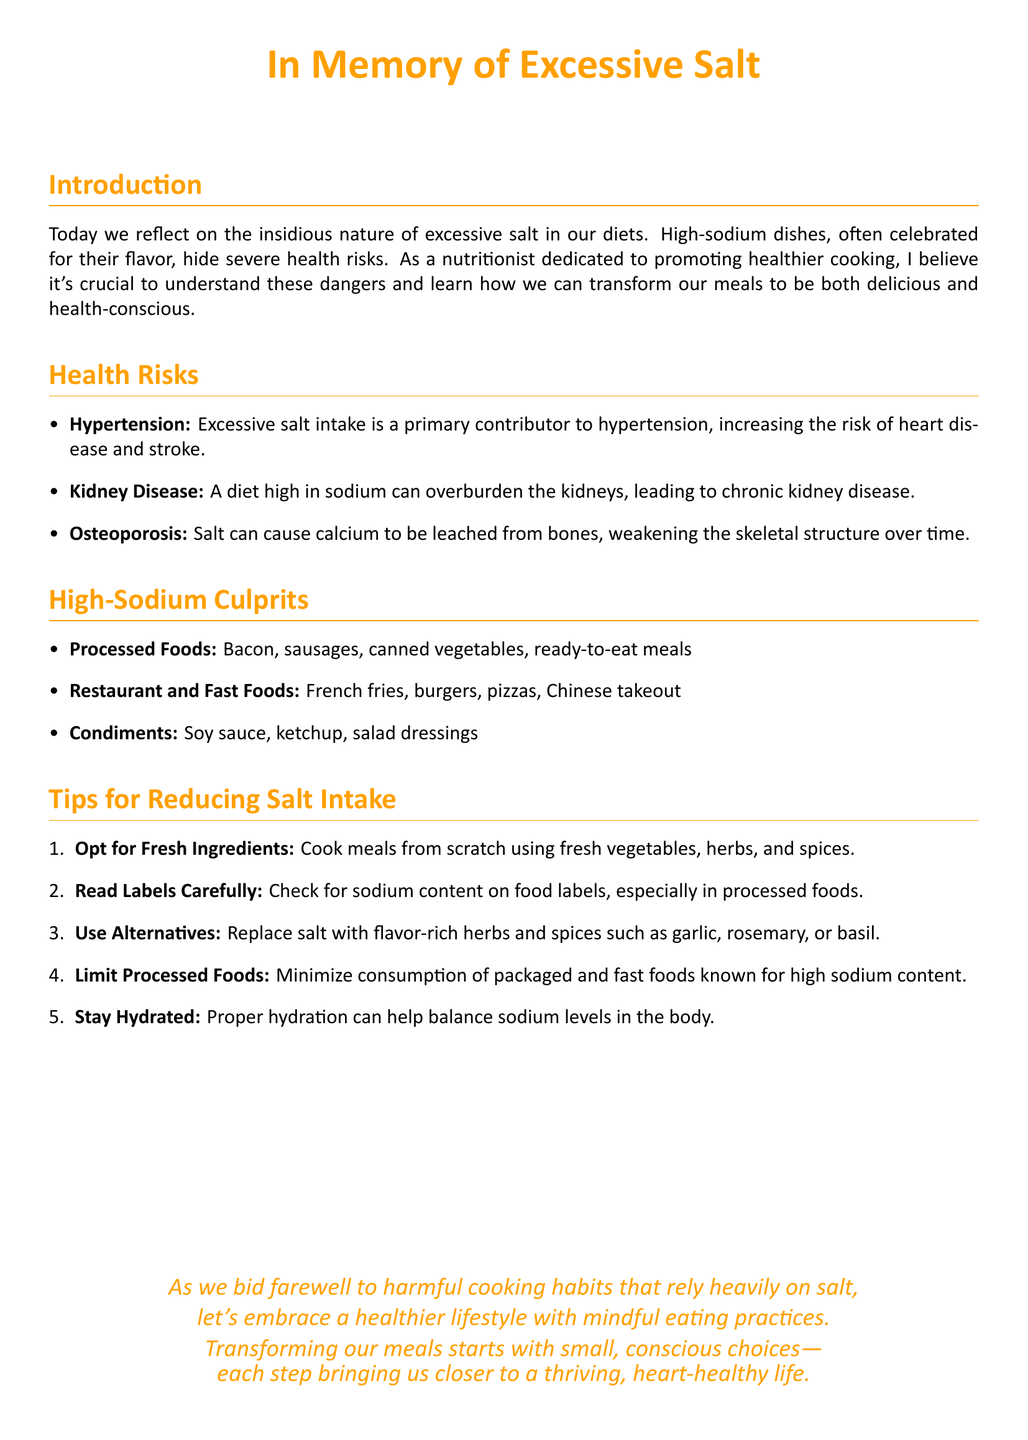What is the primary health risk associated with excessive salt intake? The document states that excessive salt intake is a primary contributor to hypertension, which increases the risk of heart disease and stroke.
Answer: Hypertension Name one type of food high in sodium mentioned. The document lists several high-sodium culprits including processed foods like bacon, sausages, and canned vegetables.
Answer: Bacon How many tips for reducing salt intake are provided? The document lists five tips for reducing salt intake.
Answer: Five What natural alternatives can be used instead of salt? The document suggests replacing salt with flavor-rich herbs and spices such as garlic, rosemary, or basil.
Answer: Garlic, rosemary, basil Which health condition is linked to calcium being leached from bones? The document states that excessive salt can lead to osteoporosis by causing calcium to be leached from bones.
Answer: Osteoporosis What is the call to action presented at the end of the document? The document encourages embracing a healthier lifestyle with mindful eating practices.
Answer: Embrace a healthier lifestyle with mindful eating practices Identify one type of restaurant food listed as high in sodium. The document mentions French fries as a high-sodium restaurant food.
Answer: French fries 